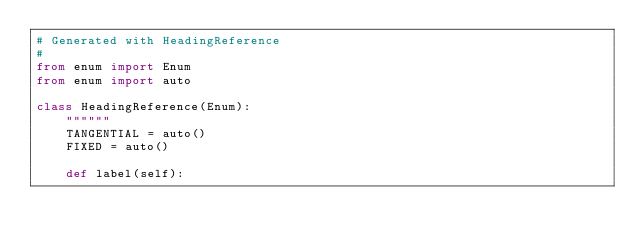<code> <loc_0><loc_0><loc_500><loc_500><_Python_># Generated with HeadingReference
# 
from enum import Enum
from enum import auto

class HeadingReference(Enum):
    """"""
    TANGENTIAL = auto()
    FIXED = auto()

    def label(self):</code> 